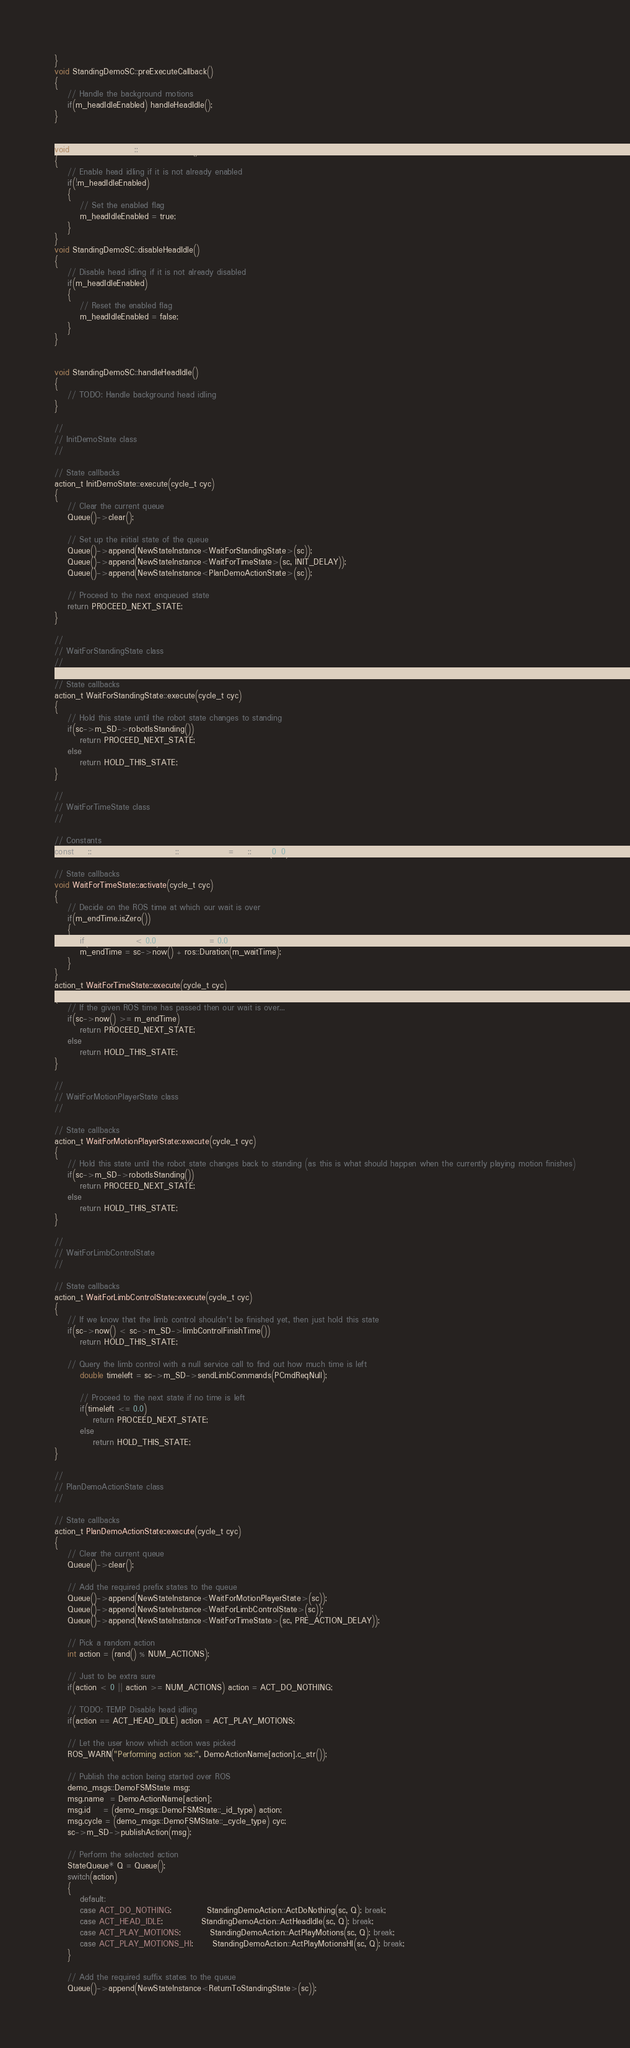<code> <loc_0><loc_0><loc_500><loc_500><_C++_>}
void StandingDemoSC::preExecuteCallback()
{
	// Handle the background motions
	if(m_headIdleEnabled) handleHeadIdle();
}


void StandingDemoSC::enableHeadIdle()
{
	// Enable head idling if it is not already enabled
	if(!m_headIdleEnabled)
	{
		// Set the enabled flag
		m_headIdleEnabled = true;
	}
}
void StandingDemoSC::disableHeadIdle()
{
	// Disable head idling if it is not already disabled
	if(m_headIdleEnabled)
	{
		// Reset the enabled flag
		m_headIdleEnabled = false;
	}
}


void StandingDemoSC::handleHeadIdle()
{
	// TODO: Handle background head idling
}

//
// InitDemoState class
//

// State callbacks
action_t InitDemoState::execute(cycle_t cyc)
{
	// Clear the current queue
	Queue()->clear();
	
	// Set up the initial state of the queue
	Queue()->append(NewStateInstance<WaitForStandingState>(sc));
	Queue()->append(NewStateInstance<WaitForTimeState>(sc, INIT_DELAY));
	Queue()->append(NewStateInstance<PlanDemoActionState>(sc));
	
	// Proceed to the next enqueued state
	return PROCEED_NEXT_STATE;
}

//
// WaitForStandingState class
//

// State callbacks
action_t WaitForStandingState::execute(cycle_t cyc)
{
	// Hold this state until the robot state changes to standing
	if(sc->m_SD->robotIsStanding())
		return PROCEED_NEXT_STATE;
	else
		return HOLD_THIS_STATE;
}

//
// WaitForTimeState class
//

// Constants
const ros::Time WaitForTimeState::NullROSTime = ros::Time(0, 0);

// State callbacks
void WaitForTimeState::activate(cycle_t cyc)
{
	// Decide on the ROS time at which our wait is over
	if(m_endTime.isZero())
	{
		if(m_waitTime < 0.0) m_waitTime = 0.0;
		m_endTime = sc->now() + ros::Duration(m_waitTime);
	}
}
action_t WaitForTimeState::execute(cycle_t cyc)
{
	// If the given ROS time has passed then our wait is over...
	if(sc->now() >= m_endTime)
		return PROCEED_NEXT_STATE;
	else
		return HOLD_THIS_STATE;
}

//
// WaitForMotionPlayerState class
//

// State callbacks
action_t WaitForMotionPlayerState::execute(cycle_t cyc)
{
	// Hold this state until the robot state changes back to standing (as this is what should happen when the currently playing motion finishes)
	if(sc->m_SD->robotIsStanding())
		return PROCEED_NEXT_STATE;
	else
		return HOLD_THIS_STATE;
}

//
// WaitForLimbControlState
//

// State callbacks
action_t WaitForLimbControlState::execute(cycle_t cyc)
{
	// If we know that the limb control shouldn't be finished yet, then just hold this state
	if(sc->now() < sc->m_SD->limbControlFinishTime())
		return HOLD_THIS_STATE;
	
	// Query the limb control with a null service call to find out how much time is left
		double timeleft = sc->m_SD->sendLimbCommands(PCmdReqNull);
		
		// Proceed to the next state if no time is left
		if(timeleft <= 0.0)
			return PROCEED_NEXT_STATE;
		else
			return HOLD_THIS_STATE;
}

//
// PlanDemoActionState class
//

// State callbacks
action_t PlanDemoActionState::execute(cycle_t cyc)
{
	// Clear the current queue
	Queue()->clear();
	
	// Add the required prefix states to the queue
	Queue()->append(NewStateInstance<WaitForMotionPlayerState>(sc));
	Queue()->append(NewStateInstance<WaitForLimbControlState>(sc));
	Queue()->append(NewStateInstance<WaitForTimeState>(sc, PRE_ACTION_DELAY));
	
	// Pick a random action
	int action = (rand() % NUM_ACTIONS);
	
	// Just to be extra sure
	if(action < 0 || action >= NUM_ACTIONS) action = ACT_DO_NOTHING;

	// TODO: TEMP Disable head idling
	if(action == ACT_HEAD_IDLE) action = ACT_PLAY_MOTIONS;

	// Let the user know which action was picked
	ROS_WARN("Performing action %s:", DemoActionName[action].c_str());
	
	// Publish the action being started over ROS
	demo_msgs::DemoFSMState msg;
	msg.name  = DemoActionName[action];
	msg.id    = (demo_msgs::DemoFSMState::_id_type) action;
	msg.cycle = (demo_msgs::DemoFSMState::_cycle_type) cyc;
	sc->m_SD->publishAction(msg);

	// Perform the selected action
	StateQueue* Q = Queue();
	switch(action)
	{
		default:
		case ACT_DO_NOTHING:           StandingDemoAction::ActDoNothing(sc, Q); break;
		case ACT_HEAD_IDLE:            StandingDemoAction::ActHeadIdle(sc, Q); break;
		case ACT_PLAY_MOTIONS:         StandingDemoAction::ActPlayMotions(sc, Q); break;
		case ACT_PLAY_MOTIONS_HI:      StandingDemoAction::ActPlayMotionsHI(sc, Q); break;
	}

	// Add the required suffix states to the queue
	Queue()->append(NewStateInstance<ReturnToStandingState>(sc));</code> 